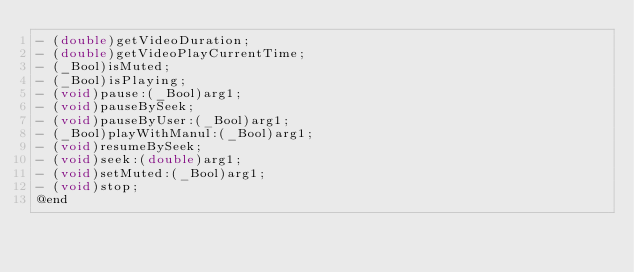<code> <loc_0><loc_0><loc_500><loc_500><_C_>- (double)getVideoDuration;
- (double)getVideoPlayCurrentTime;
- (_Bool)isMuted;
- (_Bool)isPlaying;
- (void)pause:(_Bool)arg1;
- (void)pauseBySeek;
- (void)pauseByUser:(_Bool)arg1;
- (_Bool)playWithManul:(_Bool)arg1;
- (void)resumeBySeek;
- (void)seek:(double)arg1;
- (void)setMuted:(_Bool)arg1;
- (void)stop;
@end

</code> 